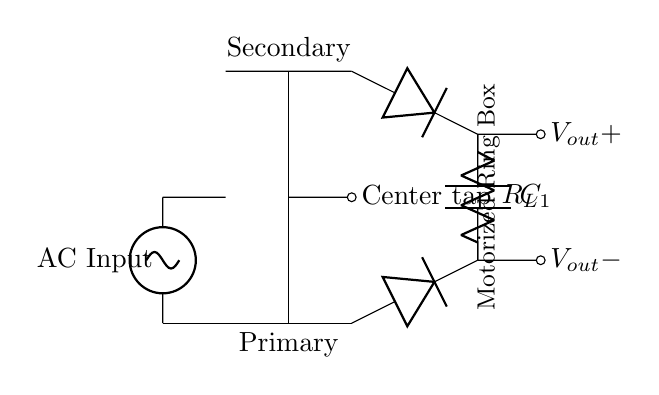what is the type of transformer used? The transformer is a center-tapped transformer, characterized by its connection that allows for two equal voltage outputs from the center tap.
Answer: center-tapped how many diodes are in the rectifier? There are two diodes in the rectifier, which are used to convert the AC voltage to DC voltage by allowing current to flow in one direction only.
Answer: two diodes what type of capacitor is used in this circuit? The circuit uses a smoothing capacitor, also known as a filter capacitor, which helps to reduce the ripple in the output voltage by storing charge and releasing it during the intervals of low voltage.
Answer: smoothing capacitor what is connected to the center tap? The center tap is connected to the AC source, which provides the alternating voltage needed for rectification.
Answer: AC source what does the load resistor represent? The load resistor represents the device or component that the circuit is powering, in this case, the motorized ring box that needs a stable DC voltage for operation.
Answer: motorized ring box why is a smoothing capacitor used after the diodes? A smoothing capacitor is used after the diodes to minimize fluctuations in the output voltage (ripple) by charging when the voltage is high and discharging when it is low, providing a more stable DC output.
Answer: minimize ripple what is the output voltage configuration? The output voltage is a bipolar configuration, with a positive and a negative terminal, indicating that it supplies direct current to the load.
Answer: bipolar configuration 